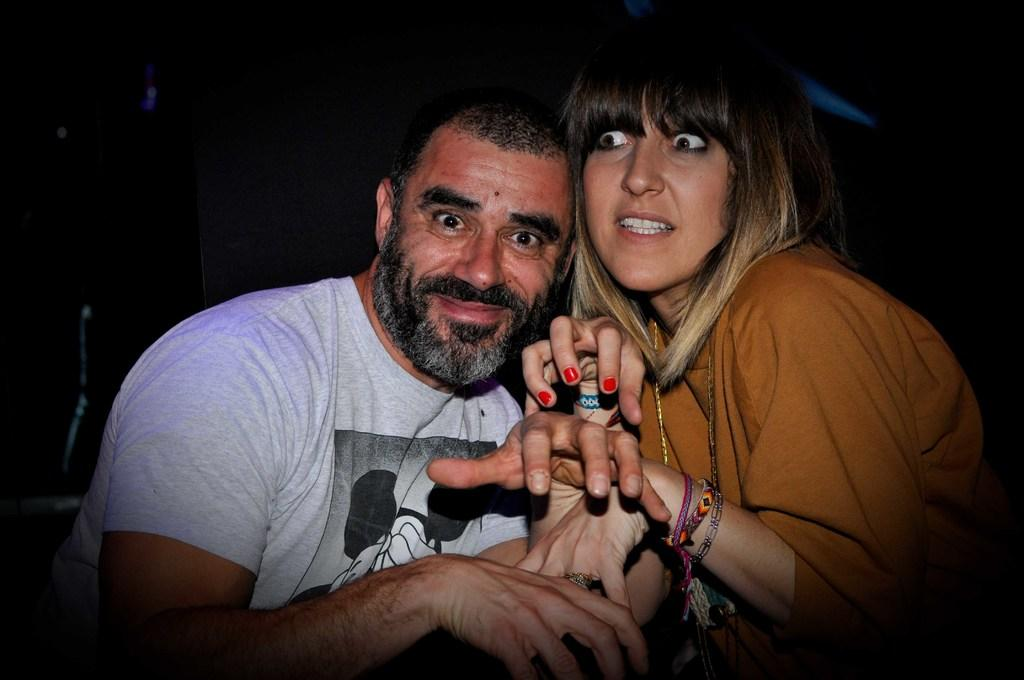How many people are in the image? There are two persons in the image. What can be observed about the background of the image? The background of the image is dark. What type of watch can be seen on the wrist of the person in the image? There is no watch visible on the wrist of any person in the image. 